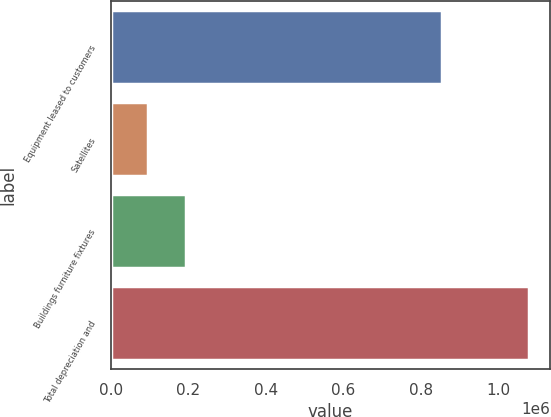<chart> <loc_0><loc_0><loc_500><loc_500><bar_chart><fcel>Equipment leased to customers<fcel>Satellites<fcel>Buildings furniture fixtures<fcel>Total depreciation and<nl><fcel>854759<fcel>95766<fcel>193983<fcel>1.07794e+06<nl></chart> 